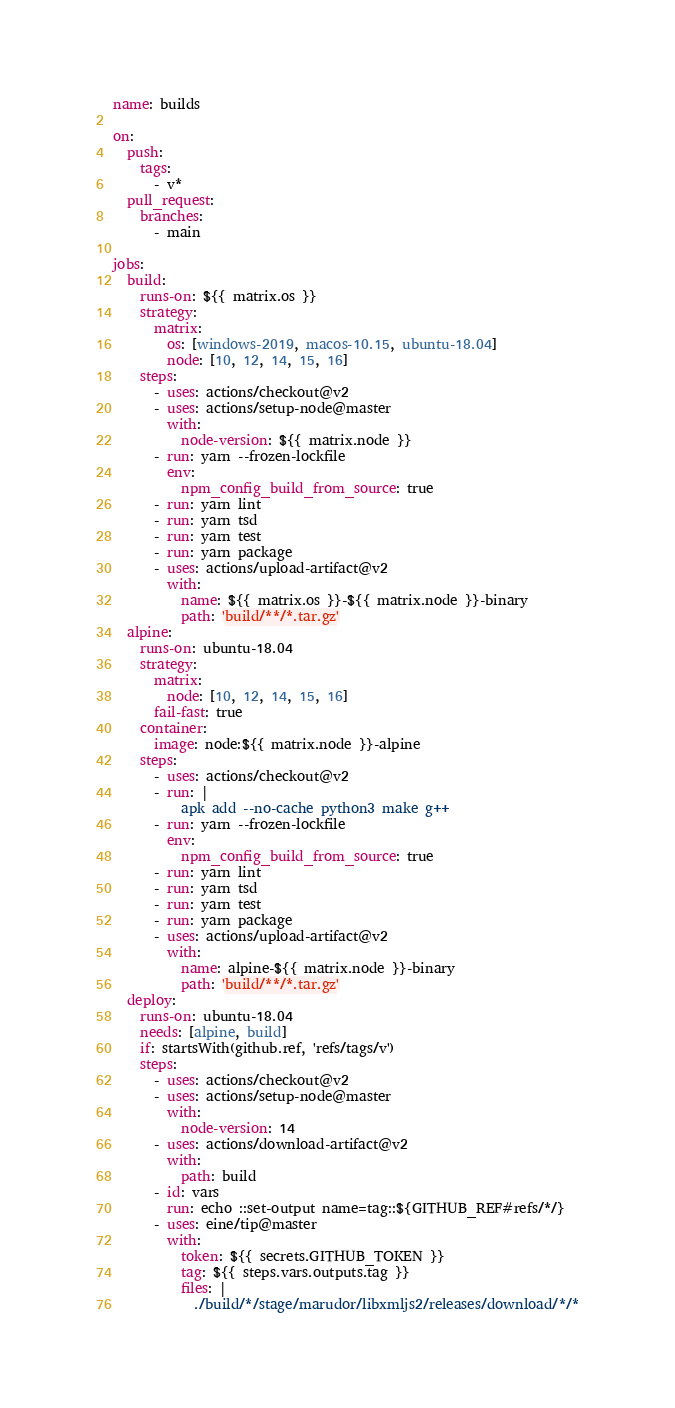Convert code to text. <code><loc_0><loc_0><loc_500><loc_500><_YAML_>name: builds

on:
  push:
    tags:
      - v*
  pull_request:
    branches:
      - main

jobs:
  build:
    runs-on: ${{ matrix.os }}
    strategy:
      matrix:
        os: [windows-2019, macos-10.15, ubuntu-18.04]
        node: [10, 12, 14, 15, 16]
    steps:
      - uses: actions/checkout@v2
      - uses: actions/setup-node@master
        with:
          node-version: ${{ matrix.node }}
      - run: yarn --frozen-lockfile
        env:
          npm_config_build_from_source: true
      - run: yarn lint
      - run: yarn tsd
      - run: yarn test
      - run: yarn package
      - uses: actions/upload-artifact@v2
        with:
          name: ${{ matrix.os }}-${{ matrix.node }}-binary
          path: 'build/**/*.tar.gz'
  alpine:
    runs-on: ubuntu-18.04
    strategy:
      matrix:
        node: [10, 12, 14, 15, 16]
      fail-fast: true
    container:
      image: node:${{ matrix.node }}-alpine
    steps:
      - uses: actions/checkout@v2
      - run: |
          apk add --no-cache python3 make g++
      - run: yarn --frozen-lockfile
        env:
          npm_config_build_from_source: true
      - run: yarn lint
      - run: yarn tsd
      - run: yarn test
      - run: yarn package
      - uses: actions/upload-artifact@v2
        with:
          name: alpine-${{ matrix.node }}-binary
          path: 'build/**/*.tar.gz'
  deploy:
    runs-on: ubuntu-18.04
    needs: [alpine, build]
    if: startsWith(github.ref, 'refs/tags/v')
    steps:
      - uses: actions/checkout@v2
      - uses: actions/setup-node@master
        with:
          node-version: 14
      - uses: actions/download-artifact@v2
        with:
          path: build
      - id: vars
        run: echo ::set-output name=tag::${GITHUB_REF#refs/*/}
      - uses: eine/tip@master
        with:
          token: ${{ secrets.GITHUB_TOKEN }}
          tag: ${{ steps.vars.outputs.tag }}
          files: |
            ./build/*/stage/marudor/libxmljs2/releases/download/*/*
</code> 